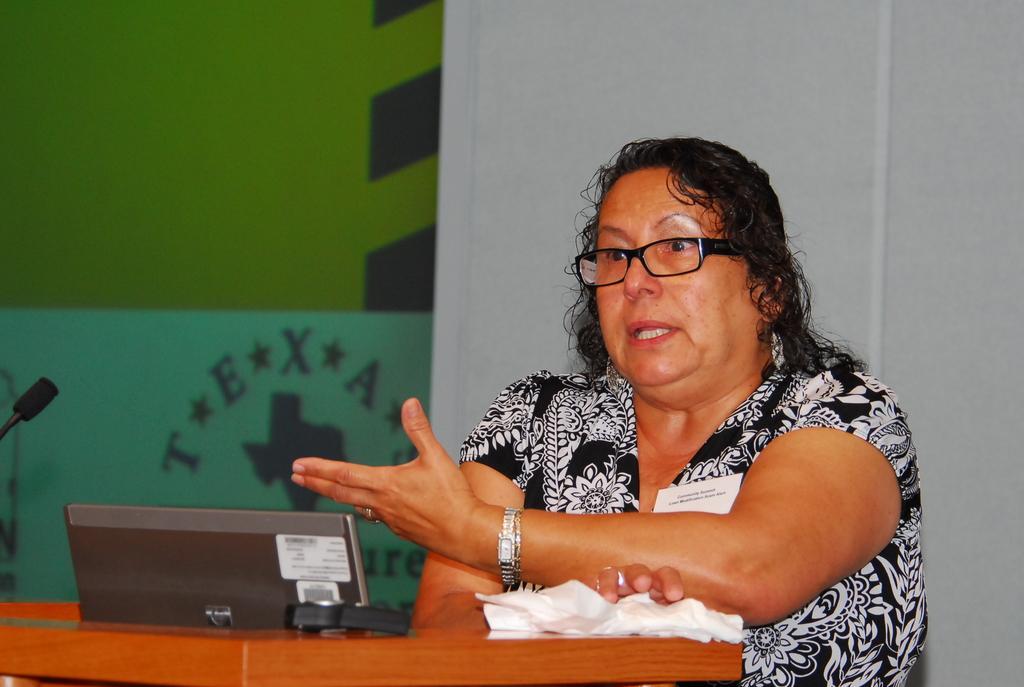Could you give a brief overview of what you see in this image? In the foreground of the picture we can see table, desktop and a woman. The woman is talking. On the left there is a mic. In the background we can see wall and glass. 